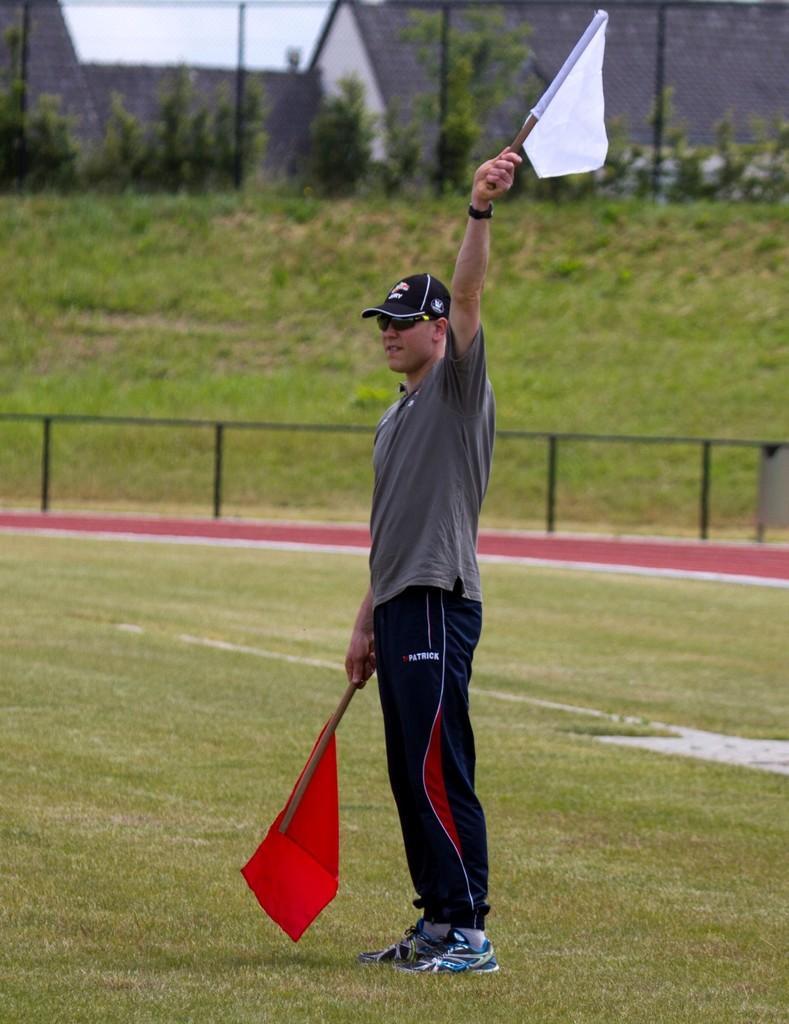Describe this image in one or two sentences. In this image we can see a man is standing by holding red and white color flags in his hand and he is wearing grey color t-shirt with purple track and black cap. The land is full of grass. Behind him fence is present and trees are there. 